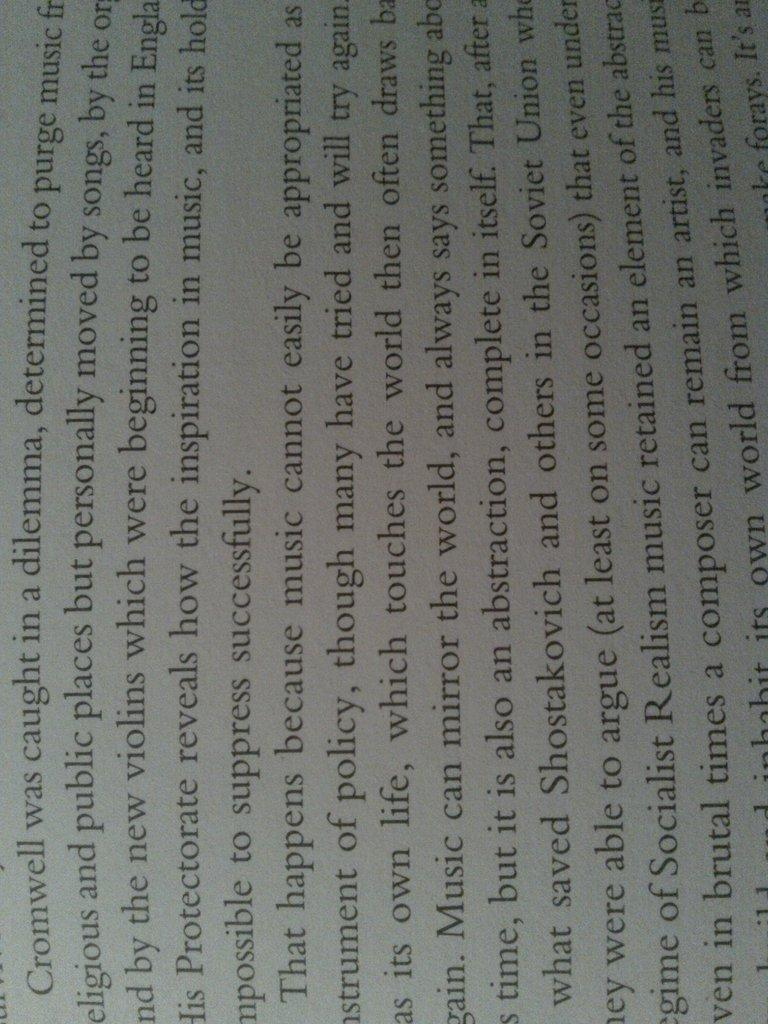<image>
Give a short and clear explanation of the subsequent image. a sideways piece of text which begins with the word Cromwell. 